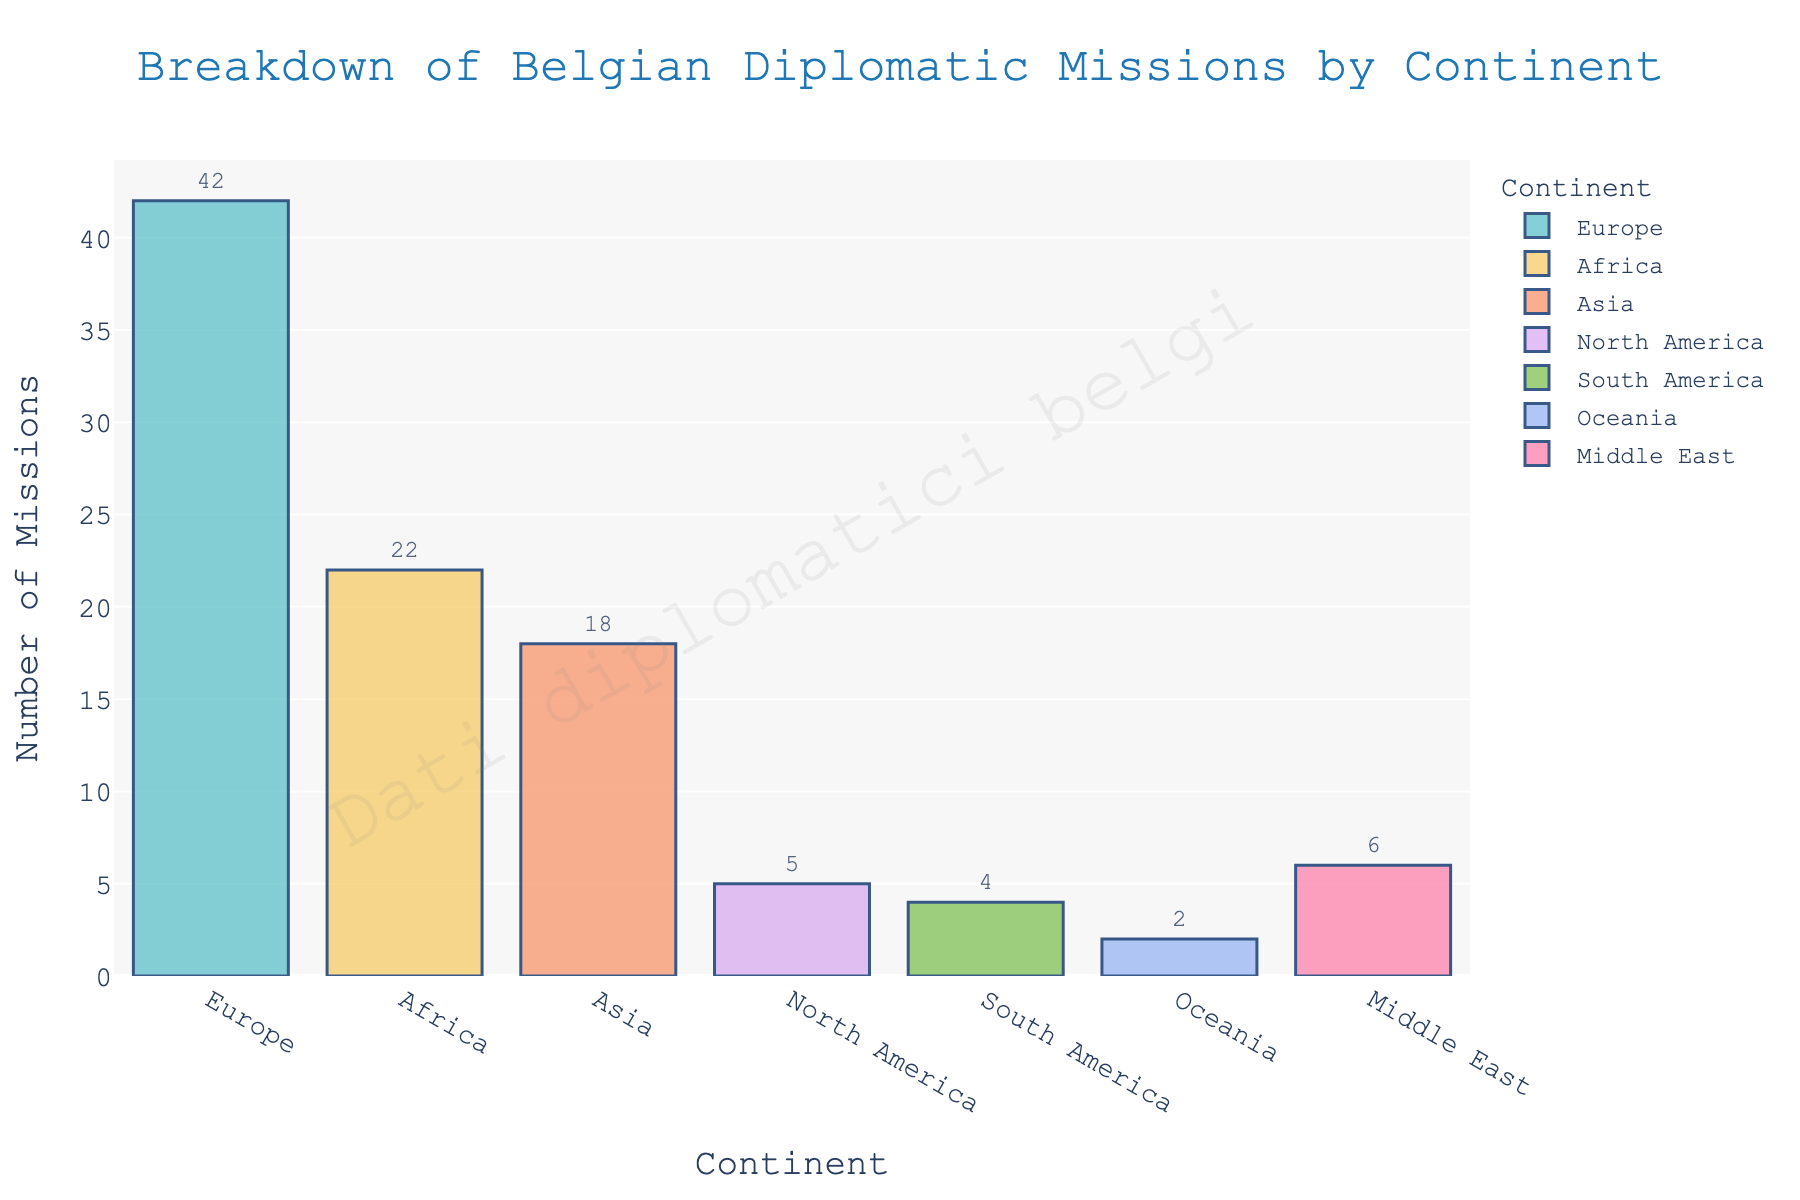Which continent has the highest number of Belgian diplomatic missions? By looking at the height of the bars, we see that Europe has the highest bar among all continents, indicating the highest number of missions.
Answer: Europe Which continents have fewer than 10 Belgian diplomatic missions? By examining the bars' heights, we see that the bars for North America, South America, and Oceania are all lower than that of 10.
Answer: North America, South America, Oceania How many more Belgian diplomatic missions are there in Asia than in South America? From the figure, Asia has 18 missions and South America has 4. Subtract 4 from 18 to find the difference.
Answer: 14 What is the total number of Belgian diplomatic missions in Africa and the Middle East combined? Add the number of missions in Africa (22) and the Middle East (6) together.
Answer: 28 Which continent has the second-highest number of Belgian diplomatic missions? Looking at the height of the bars, Africa has the second-highest bar after Europe.
Answer: Africa Compare the number of Belgian diplomatic missions in North America and Oceania. Which one has more missions and by how much? North America has 5 missions, while Oceania has 2. Subtract 2 from 5 to find the difference.
Answer: North America, 3 What is the average number of Belgian diplomatic missions per continent? Sum all the missions (42 + 22 + 18 + 5 + 4 + 2 + 6) = 99 and divide by the number of continents (7). 99 divided by 7 is approximately 14.14.
Answer: 14.14 Are there more Belgian diplomatic missions in the Middle East or in South America? The bar for the Middle East is taller than that for South America, showing 6 missions compared to South America's 4.
Answer: Middle East What is the median number of Belgian diplomatic missions among all continents? Arrange the number of missions in ascending order: 2, 4, 5, 6, 18, 22, 42. The median is the middle value, which is 6.
Answer: Middle East 